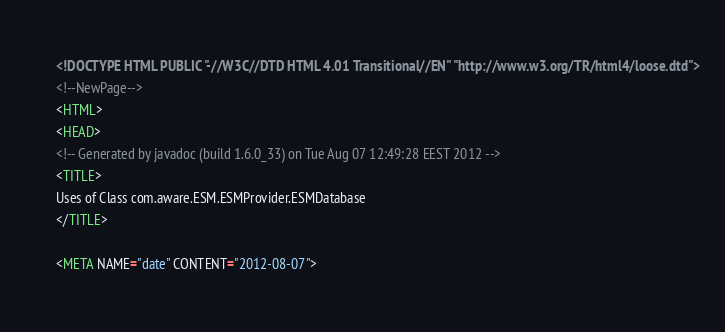Convert code to text. <code><loc_0><loc_0><loc_500><loc_500><_HTML_><!DOCTYPE HTML PUBLIC "-//W3C//DTD HTML 4.01 Transitional//EN" "http://www.w3.org/TR/html4/loose.dtd">
<!--NewPage-->
<HTML>
<HEAD>
<!-- Generated by javadoc (build 1.6.0_33) on Tue Aug 07 12:49:28 EEST 2012 -->
<TITLE>
Uses of Class com.aware.ESM.ESMProvider.ESMDatabase
</TITLE>

<META NAME="date" CONTENT="2012-08-07">
</code> 